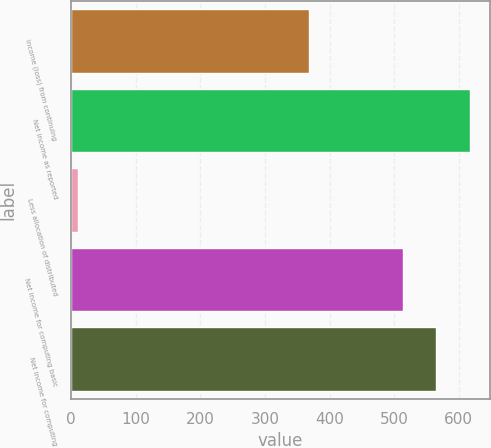Convert chart. <chart><loc_0><loc_0><loc_500><loc_500><bar_chart><fcel>Income (loss) from continuing<fcel>Net income as reported<fcel>Less allocation of distributed<fcel>Net income for computing basic<fcel>Net income for computing<nl><fcel>368.4<fcel>616.8<fcel>11<fcel>514<fcel>565.4<nl></chart> 